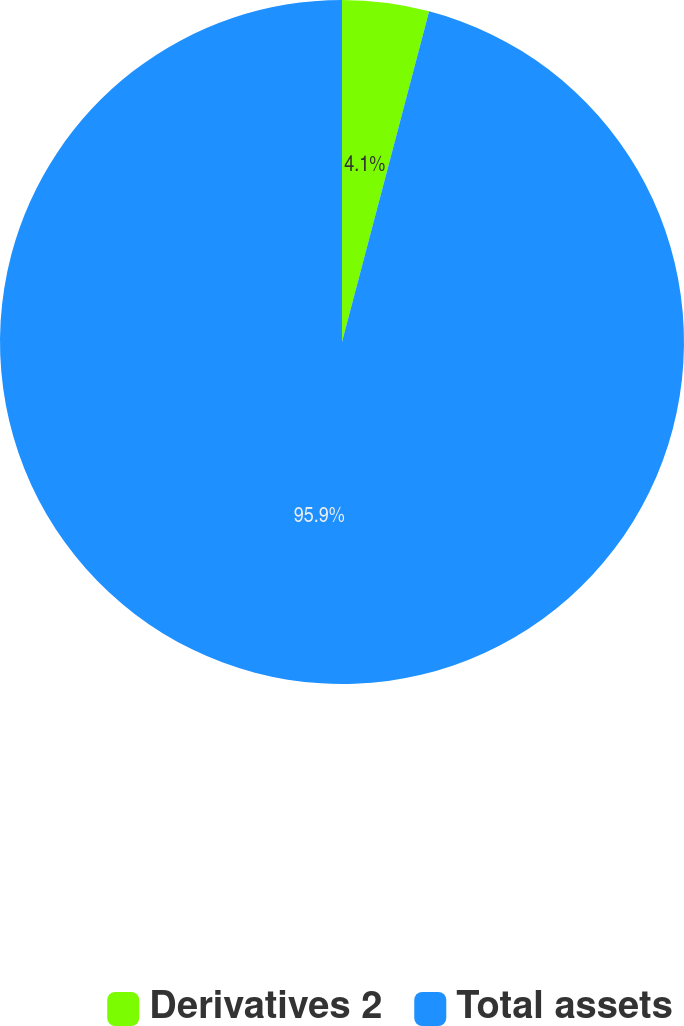Convert chart to OTSL. <chart><loc_0><loc_0><loc_500><loc_500><pie_chart><fcel>Derivatives 2<fcel>Total assets<nl><fcel>4.1%<fcel>95.9%<nl></chart> 